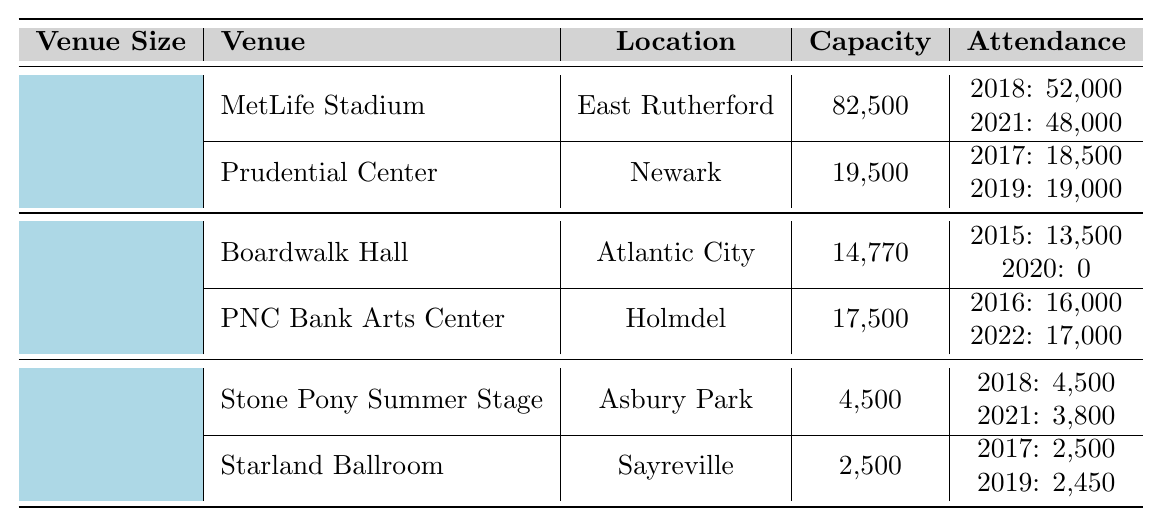What is the total attendance at MetLife Stadium in 2018 and 2021? In 2018, MetLife Stadium had an attendance of 52,000 and in 2021 it had 48,000. Adding these two values gives a total attendance of 52,000 + 48,000 = 100,000.
Answer: 100,000 What was the attendance at Boardwalk Hall in 2020? According to the table, Boardwalk Hall had an attendance of 0 in 2020.
Answer: 0 Which venue had the highest capacity? The MetLife Stadium has the highest capacity listed in the table, which is 82,500.
Answer: MetLife Stadium How many attendees were present at the Stone Pony Summer Stage in 2021? The table indicates that the Stone Pony Summer Stage had an attendance of 3,800 in 2021.
Answer: 3,800 What is the average attendance at the Prudential Center for its recorded years? The Prudential Center had attendances of 18,500 in 2017 and 19,000 in 2019. To find the average, we sum these values (18,500 + 19,000 = 37,500) and divide by 2, yielding an average of 37,500 / 2 = 18,750.
Answer: 18,750 Was there a concert at PNC Bank Arts Center in 2021? The table does not record any attendance for PNC Bank Arts Center in 2021, so the answer is no.
Answer: No What was the total attendance at Starland Ballroom across the years it hosted concerts? Starland Ballroom had attendances of 2,500 in 2017 and 2,450 in 2019. Adding these figures together (2,500 + 2,450) results in a total attendance of 4,950.
Answer: 4,950 Which venue had the lowest attendance in a single year, and what was that attendance? The lowest attendance in a single year was 0 at Boardwalk Hall in 2020.
Answer: Boardwalk Hall, 0 Calculate the total capacity of all venues combined. The total capacity can be calculated by adding the capacities of all venues: 82,500 (MetLife) + 19,500 (Prudential) + 14,770 (Boardwalk Hall) + 17,500 (PNC) + 4,500 (Stone Pony) + 2,500 (Starland) = 141,270.
Answer: 141,270 How many large venues are listed in New Jersey? The table lists two large venues: MetLife Stadium and Prudential Center.
Answer: 2 